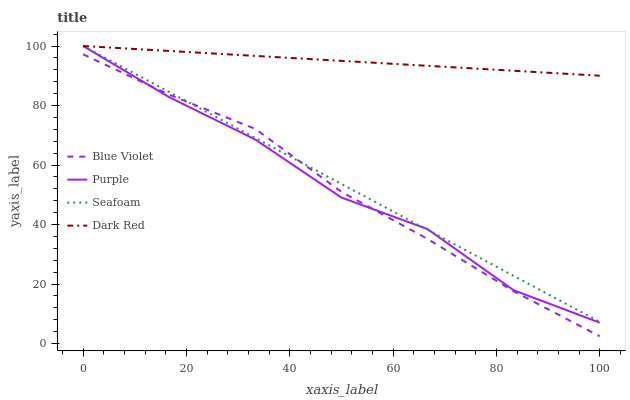Does Seafoam have the minimum area under the curve?
Answer yes or no. No. Does Seafoam have the maximum area under the curve?
Answer yes or no. No. Is Dark Red the smoothest?
Answer yes or no. No. Is Dark Red the roughest?
Answer yes or no. No. Does Seafoam have the lowest value?
Answer yes or no. No. Does Blue Violet have the highest value?
Answer yes or no. No. Is Blue Violet less than Dark Red?
Answer yes or no. Yes. Is Dark Red greater than Blue Violet?
Answer yes or no. Yes. Does Blue Violet intersect Dark Red?
Answer yes or no. No. 